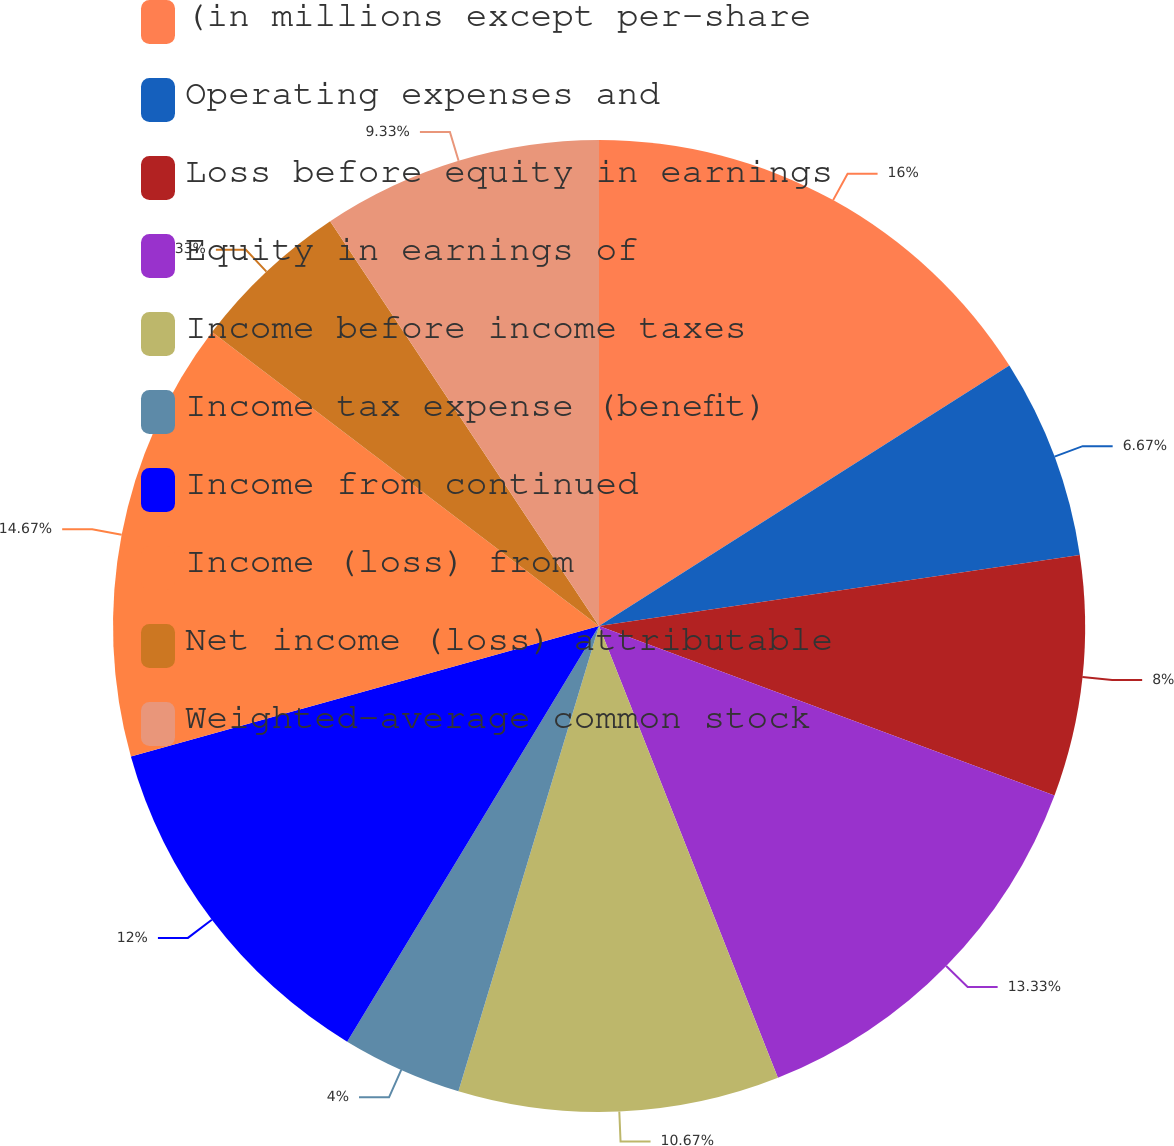Convert chart. <chart><loc_0><loc_0><loc_500><loc_500><pie_chart><fcel>(in millions except per-share<fcel>Operating expenses and<fcel>Loss before equity in earnings<fcel>Equity in earnings of<fcel>Income before income taxes<fcel>Income tax expense (benefit)<fcel>Income from continued<fcel>Income (loss) from<fcel>Net income (loss) attributable<fcel>Weighted-average common stock<nl><fcel>16.0%<fcel>6.67%<fcel>8.0%<fcel>13.33%<fcel>10.67%<fcel>4.0%<fcel>12.0%<fcel>14.67%<fcel>5.33%<fcel>9.33%<nl></chart> 